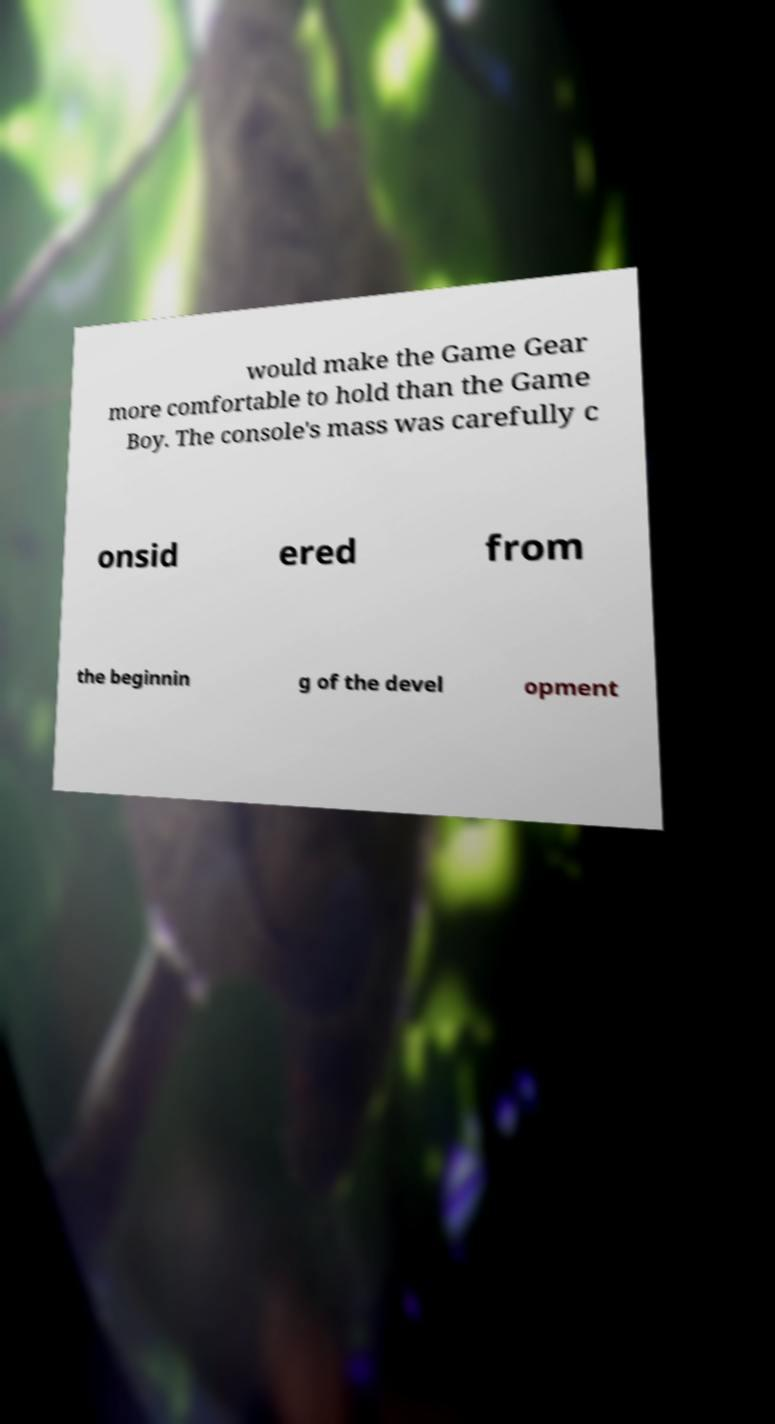Could you extract and type out the text from this image? would make the Game Gear more comfortable to hold than the Game Boy. The console's mass was carefully c onsid ered from the beginnin g of the devel opment 